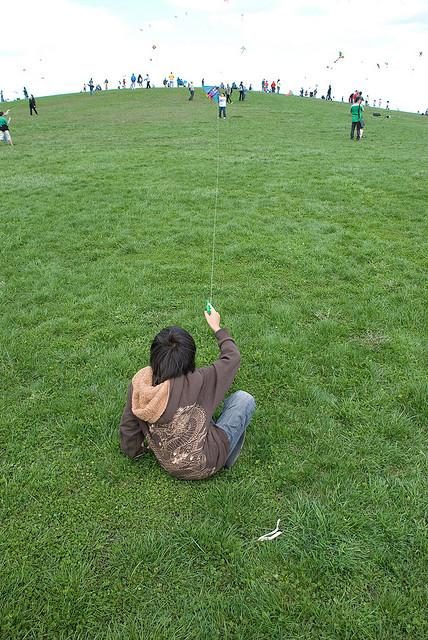What is the boy sitting in the grass doing?

Choices:
A) playing pokemon
B) resting
C) texting
D) flying kite flying kite 